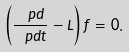<formula> <loc_0><loc_0><loc_500><loc_500>\left ( \frac { \ p d } { \ p d t } - L \right ) f = 0 .</formula> 